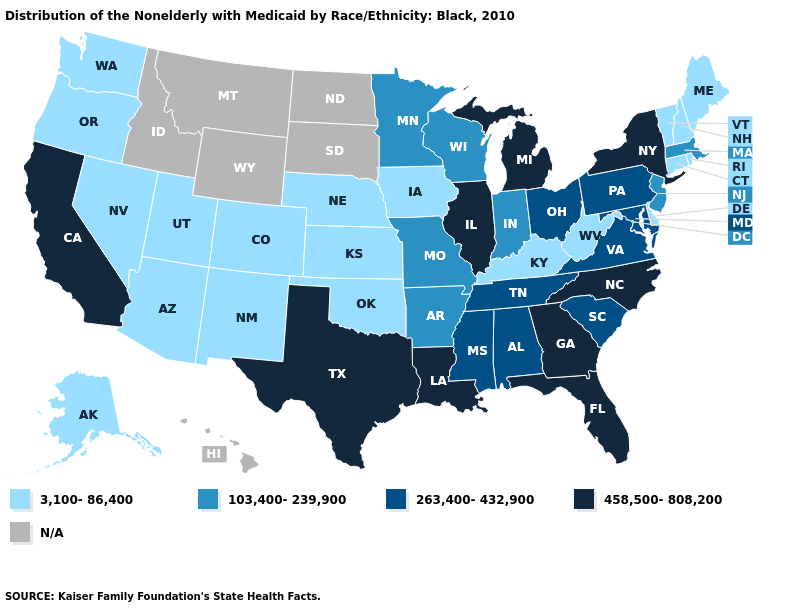Name the states that have a value in the range 458,500-808,200?
Quick response, please. California, Florida, Georgia, Illinois, Louisiana, Michigan, New York, North Carolina, Texas. What is the value of Washington?
Short answer required. 3,100-86,400. What is the value of South Carolina?
Be succinct. 263,400-432,900. Name the states that have a value in the range 103,400-239,900?
Give a very brief answer. Arkansas, Indiana, Massachusetts, Minnesota, Missouri, New Jersey, Wisconsin. Does California have the lowest value in the West?
Write a very short answer. No. Which states hav the highest value in the MidWest?
Short answer required. Illinois, Michigan. Is the legend a continuous bar?
Answer briefly. No. Which states have the lowest value in the MidWest?
Keep it brief. Iowa, Kansas, Nebraska. Among the states that border Nebraska , which have the highest value?
Be succinct. Missouri. What is the value of Arizona?
Keep it brief. 3,100-86,400. What is the lowest value in states that border New Mexico?
Give a very brief answer. 3,100-86,400. Does Maine have the lowest value in the Northeast?
Give a very brief answer. Yes. What is the value of Idaho?
Write a very short answer. N/A. Does Michigan have the lowest value in the USA?
Write a very short answer. No. 